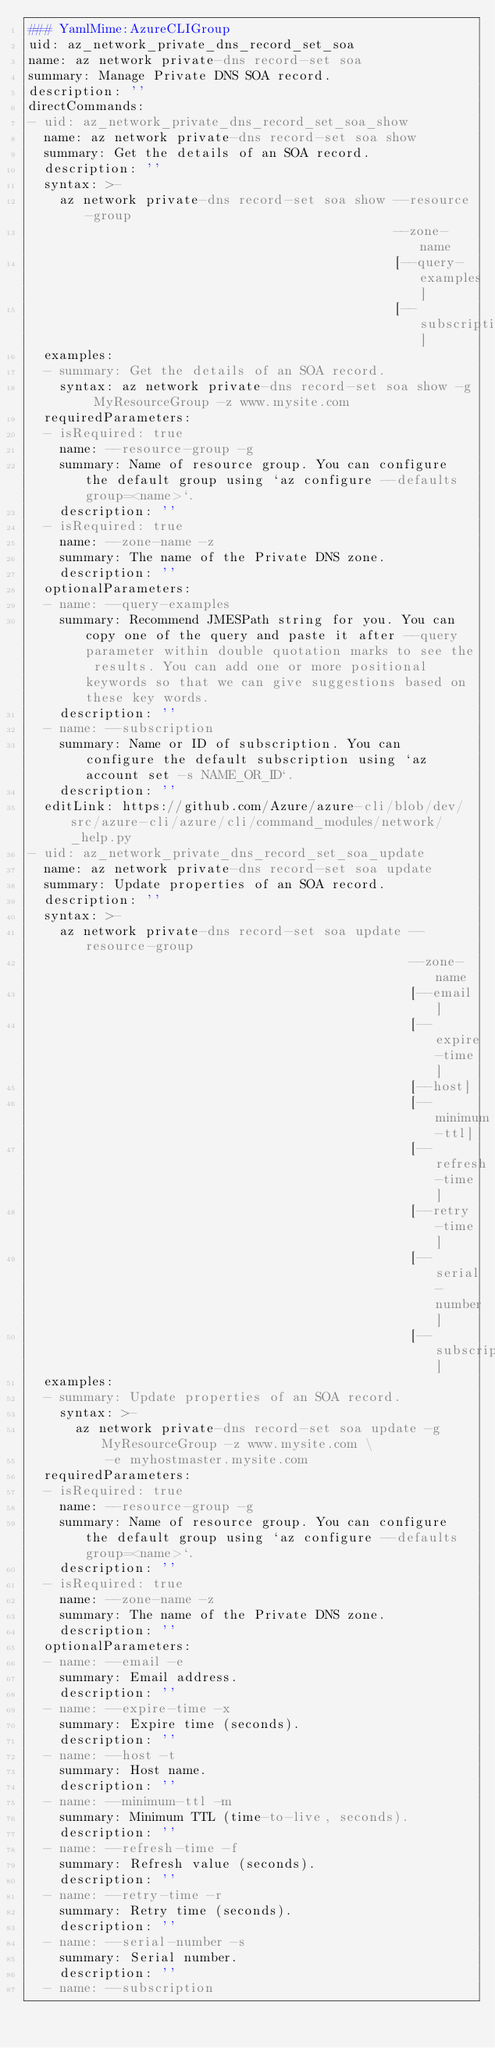<code> <loc_0><loc_0><loc_500><loc_500><_YAML_>### YamlMime:AzureCLIGroup
uid: az_network_private_dns_record_set_soa
name: az network private-dns record-set soa
summary: Manage Private DNS SOA record.
description: ''
directCommands:
- uid: az_network_private_dns_record_set_soa_show
  name: az network private-dns record-set soa show
  summary: Get the details of an SOA record.
  description: ''
  syntax: >-
    az network private-dns record-set soa show --resource-group
                                               --zone-name
                                               [--query-examples]
                                               [--subscription]
  examples:
  - summary: Get the details of an SOA record.
    syntax: az network private-dns record-set soa show -g MyResourceGroup -z www.mysite.com
  requiredParameters:
  - isRequired: true
    name: --resource-group -g
    summary: Name of resource group. You can configure the default group using `az configure --defaults group=<name>`.
    description: ''
  - isRequired: true
    name: --zone-name -z
    summary: The name of the Private DNS zone.
    description: ''
  optionalParameters:
  - name: --query-examples
    summary: Recommend JMESPath string for you. You can copy one of the query and paste it after --query parameter within double quotation marks to see the results. You can add one or more positional keywords so that we can give suggestions based on these key words.
    description: ''
  - name: --subscription
    summary: Name or ID of subscription. You can configure the default subscription using `az account set -s NAME_OR_ID`.
    description: ''
  editLink: https://github.com/Azure/azure-cli/blob/dev/src/azure-cli/azure/cli/command_modules/network/_help.py
- uid: az_network_private_dns_record_set_soa_update
  name: az network private-dns record-set soa update
  summary: Update properties of an SOA record.
  description: ''
  syntax: >-
    az network private-dns record-set soa update --resource-group
                                                 --zone-name
                                                 [--email]
                                                 [--expire-time]
                                                 [--host]
                                                 [--minimum-ttl]
                                                 [--refresh-time]
                                                 [--retry-time]
                                                 [--serial-number]
                                                 [--subscription]
  examples:
  - summary: Update properties of an SOA record.
    syntax: >-
      az network private-dns record-set soa update -g MyResourceGroup -z www.mysite.com \
          -e myhostmaster.mysite.com
  requiredParameters:
  - isRequired: true
    name: --resource-group -g
    summary: Name of resource group. You can configure the default group using `az configure --defaults group=<name>`.
    description: ''
  - isRequired: true
    name: --zone-name -z
    summary: The name of the Private DNS zone.
    description: ''
  optionalParameters:
  - name: --email -e
    summary: Email address.
    description: ''
  - name: --expire-time -x
    summary: Expire time (seconds).
    description: ''
  - name: --host -t
    summary: Host name.
    description: ''
  - name: --minimum-ttl -m
    summary: Minimum TTL (time-to-live, seconds).
    description: ''
  - name: --refresh-time -f
    summary: Refresh value (seconds).
    description: ''
  - name: --retry-time -r
    summary: Retry time (seconds).
    description: ''
  - name: --serial-number -s
    summary: Serial number.
    description: ''
  - name: --subscription</code> 